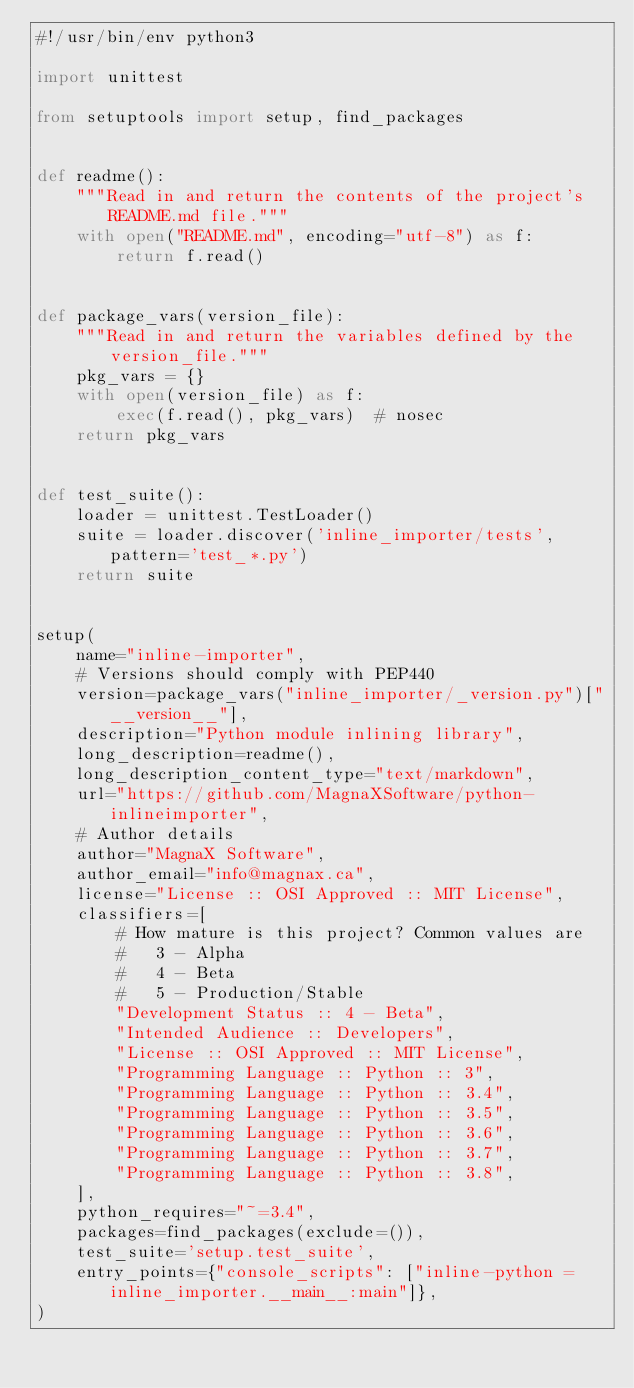<code> <loc_0><loc_0><loc_500><loc_500><_Python_>#!/usr/bin/env python3

import unittest

from setuptools import setup, find_packages


def readme():
    """Read in and return the contents of the project's README.md file."""
    with open("README.md", encoding="utf-8") as f:
        return f.read()


def package_vars(version_file):
    """Read in and return the variables defined by the version_file."""
    pkg_vars = {}
    with open(version_file) as f:
        exec(f.read(), pkg_vars)  # nosec
    return pkg_vars


def test_suite():
    loader = unittest.TestLoader()
    suite = loader.discover('inline_importer/tests', pattern='test_*.py')
    return suite


setup(
    name="inline-importer",
    # Versions should comply with PEP440
    version=package_vars("inline_importer/_version.py")["__version__"],
    description="Python module inlining library",
    long_description=readme(),
    long_description_content_type="text/markdown",
    url="https://github.com/MagnaXSoftware/python-inlineimporter",
    # Author details
    author="MagnaX Software",
    author_email="info@magnax.ca",
    license="License :: OSI Approved :: MIT License",
    classifiers=[
        # How mature is this project? Common values are
        #   3 - Alpha
        #   4 - Beta
        #   5 - Production/Stable
        "Development Status :: 4 - Beta",
        "Intended Audience :: Developers",
        "License :: OSI Approved :: MIT License",
        "Programming Language :: Python :: 3",
        "Programming Language :: Python :: 3.4",
        "Programming Language :: Python :: 3.5",
        "Programming Language :: Python :: 3.6",
        "Programming Language :: Python :: 3.7",
        "Programming Language :: Python :: 3.8",
    ],
    python_requires="~=3.4",
    packages=find_packages(exclude=()),
    test_suite='setup.test_suite',
    entry_points={"console_scripts": ["inline-python = inline_importer.__main__:main"]},
)
</code> 